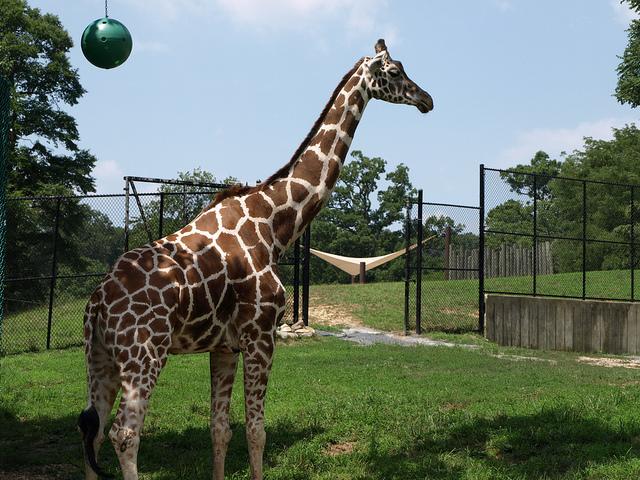Is the giraffe fully grown?
Keep it brief. Yes. What is inside the bundle hanging from the tree?
Answer briefly. Food. What is the fence made of?
Quick response, please. Metal. What is the green ball above the giraffe?
Be succinct. Toy. Overcast or sunny?
Answer briefly. Sunny. What species of giraffe are in the photo?
Keep it brief. African. Why is the giraffe standing in the park?
Be succinct. Entertainment. How much of the giraffe is in the shade?
Keep it brief. Half. 